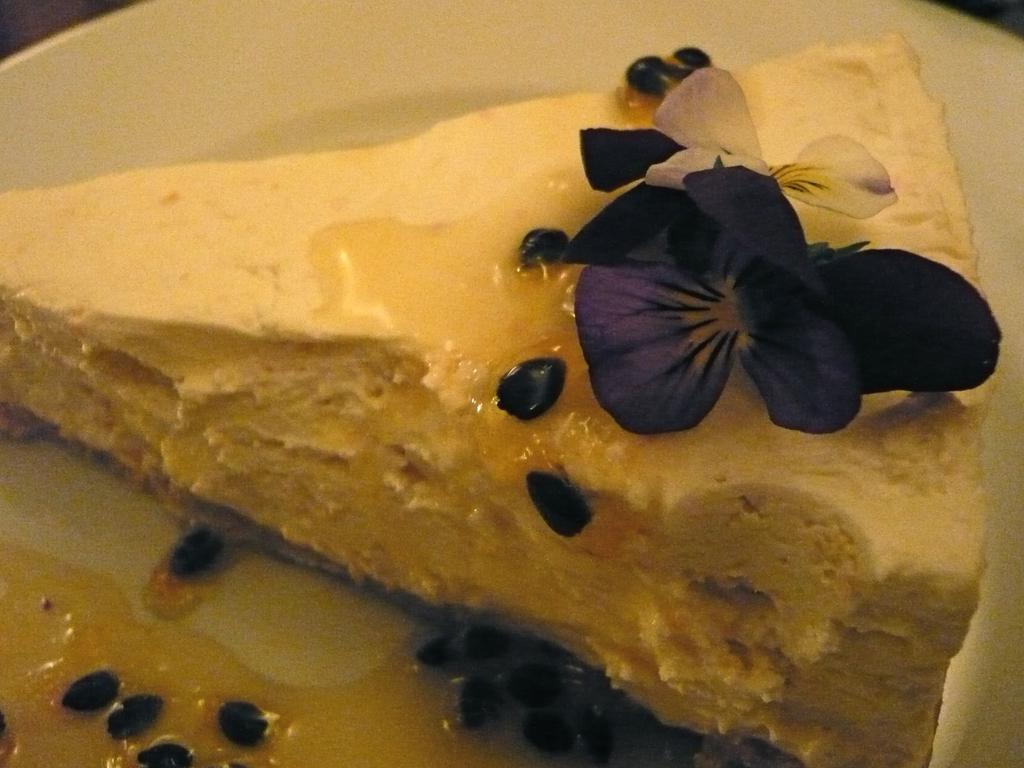How many flowers are present in the image? There are two flowers in the image. What else can be seen in the image besides the flowers? There is food on a white plate in the image. What type of paste is being used to create the flowers in the image? There is no paste or indication of any crafting materials in the image; the flowers appear to be real. 